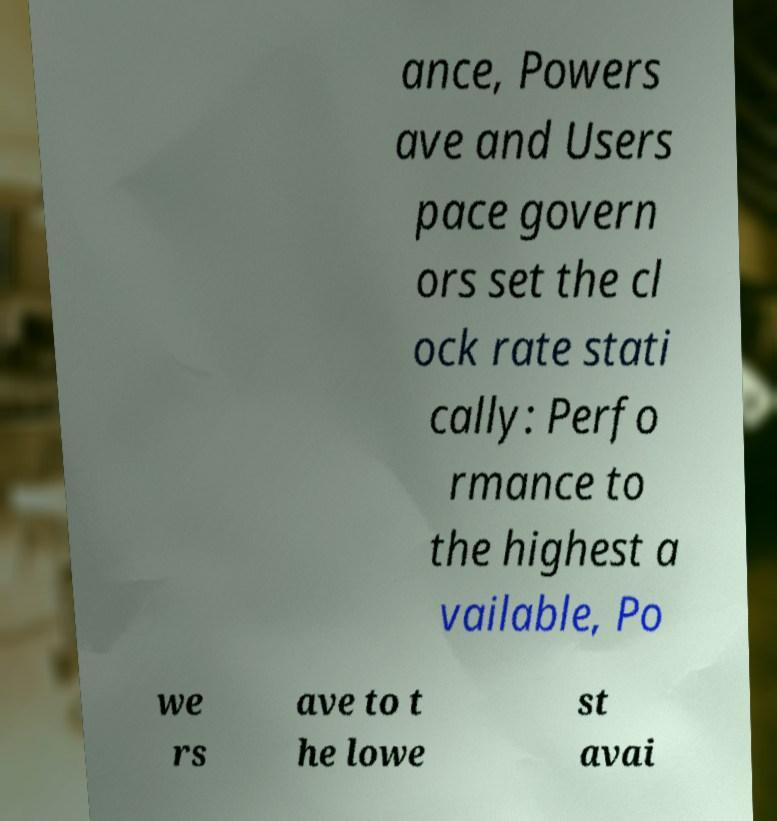Please read and relay the text visible in this image. What does it say? ance, Powers ave and Users pace govern ors set the cl ock rate stati cally: Perfo rmance to the highest a vailable, Po we rs ave to t he lowe st avai 